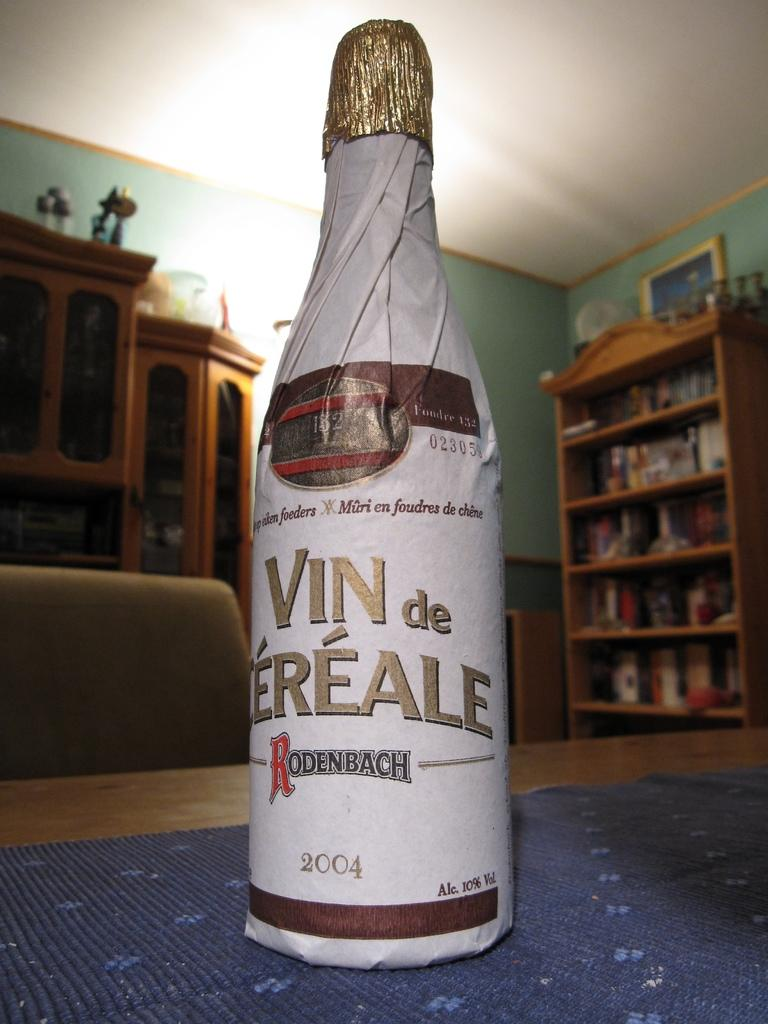<image>
Give a short and clear explanation of the subsequent image. A bottle of 2004 wine still has a paper wrapper around the whole bottle. 